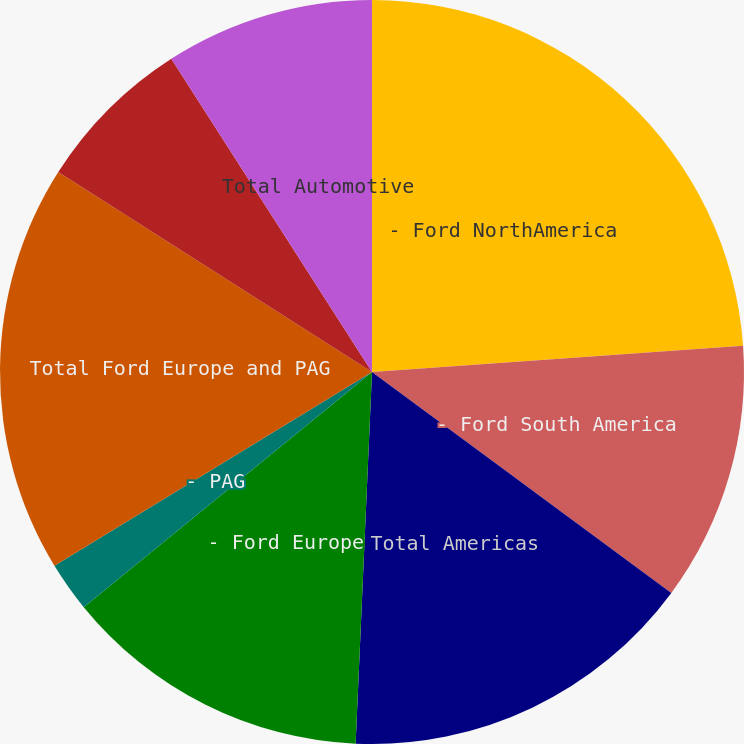Convert chart to OTSL. <chart><loc_0><loc_0><loc_500><loc_500><pie_chart><fcel>- Ford NorthAmerica<fcel>- Ford South America<fcel>Total Americas<fcel>- Ford Europe<fcel>- PAG<fcel>Total Ford Europe and PAG<fcel>Ford Asia Pacific and Africa<fcel>Total Automotive<nl><fcel>23.88%<fcel>11.24%<fcel>15.58%<fcel>13.41%<fcel>2.17%<fcel>17.75%<fcel>6.9%<fcel>9.07%<nl></chart> 